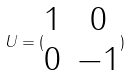Convert formula to latex. <formula><loc_0><loc_0><loc_500><loc_500>U = ( \begin{matrix} 1 & 0 \\ 0 & - 1 \end{matrix} )</formula> 